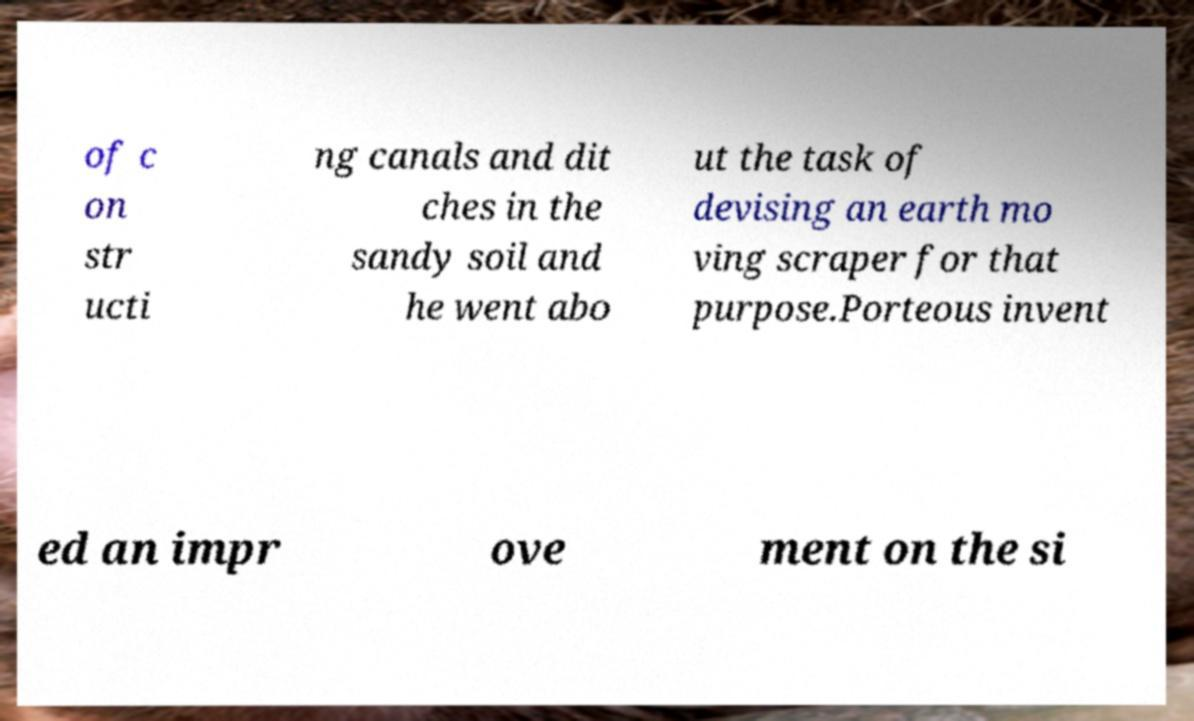Please read and relay the text visible in this image. What does it say? of c on str ucti ng canals and dit ches in the sandy soil and he went abo ut the task of devising an earth mo ving scraper for that purpose.Porteous invent ed an impr ove ment on the si 